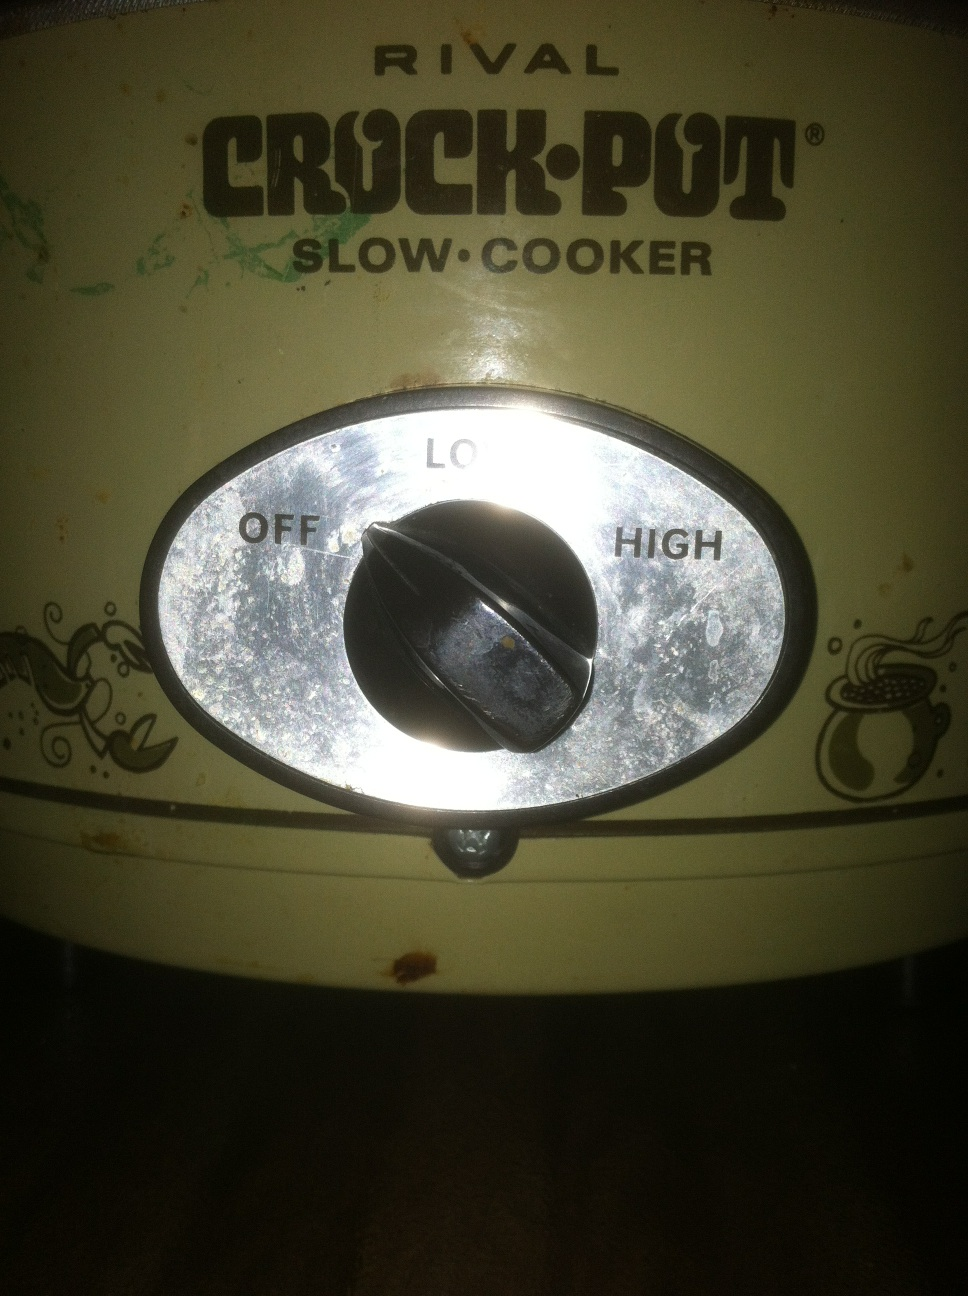Describe a cozy scenario where this crock pot would be used. Imagine a chilly autumn day; the air is crisp and leaves are painted in hues of orange and red. The house is filled with the aroma of a hearty beef stew slowly cooking in the crock pot. Everyone is gathered around a fireplace, wrapped in blankets, sipping on hot cocoa. The enticing smell wafts through the house, building anticipation. As evening approaches, family and friends gather around the table to enjoy a comforting meal together, created effortlessly in the crock pot, bringing warmth and joy to their hearts. Suggest a quick recipe that can be made today using this crock pot. One quick recipe you can prepare is Chicken Taco Soup. Just combine the following ingredients in your crock pot: 1 can of black beans, 1 can of corn, 1 can of diced tomatoes, 2 cups of chicken broth, 1 packet of taco seasoning, and 2 to 3 boneless, skinless chicken breasts. Set on high for 3-4 hours or low for 6-8 hours. Once the cooking time is done, shred the chicken, mix it back into the soup and serve with your favorite toppings like shredded cheese, sour cream, or avocado. 